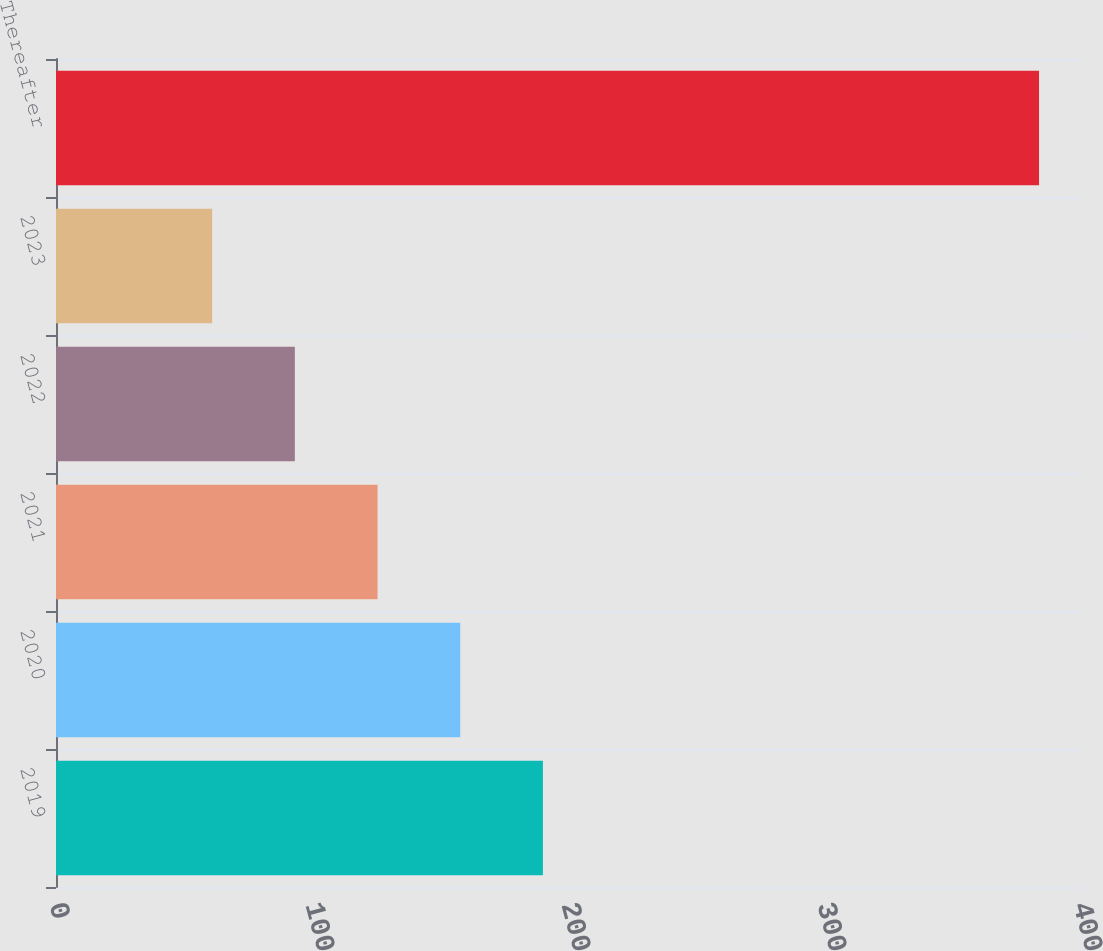<chart> <loc_0><loc_0><loc_500><loc_500><bar_chart><fcel>2019<fcel>2020<fcel>2021<fcel>2022<fcel>2023<fcel>Thereafter<nl><fcel>190.2<fcel>157.9<fcel>125.6<fcel>93.3<fcel>61<fcel>384<nl></chart> 